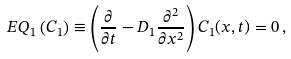Convert formula to latex. <formula><loc_0><loc_0><loc_500><loc_500>E Q _ { 1 } \left ( C _ { 1 } \right ) \equiv \left ( \frac { \partial } { \partial t } - D _ { 1 } \frac { \partial ^ { 2 } } { \partial x ^ { 2 } } \right ) C _ { 1 } ( x , t ) = 0 \, ,</formula> 